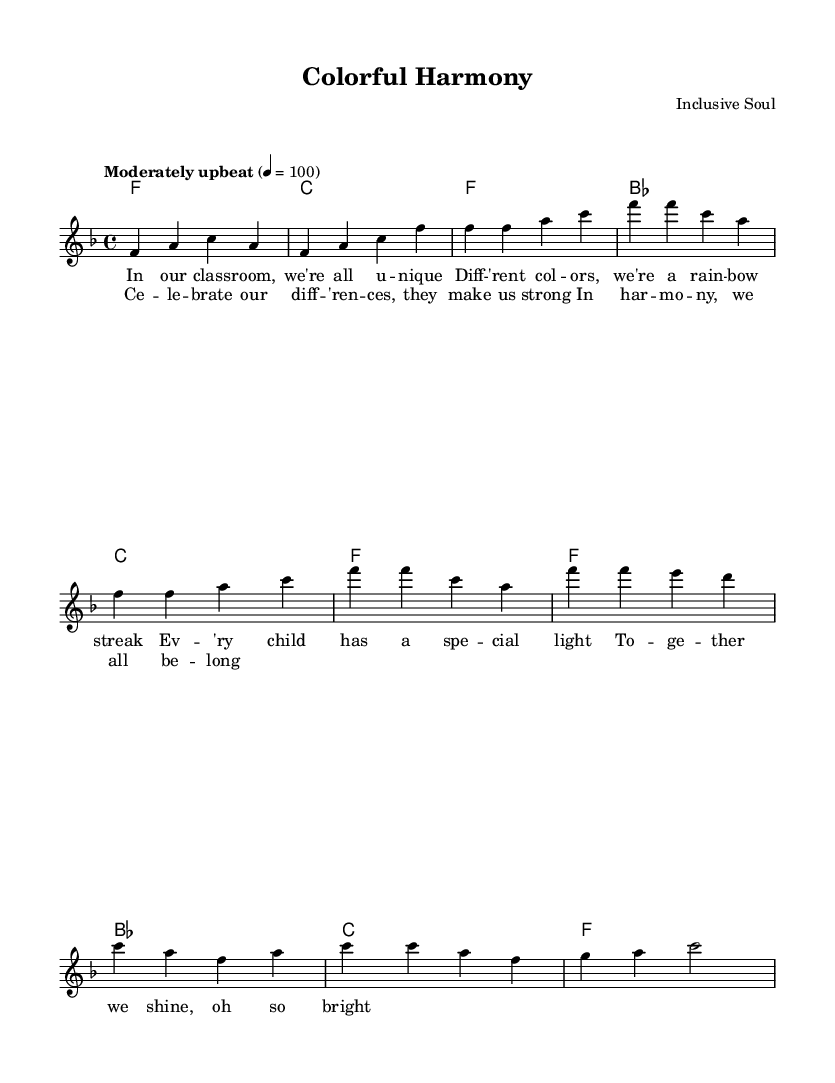What is the key signature of this music? The key signature is F major, which has one flat, B flat. This can be confirmed by looking at the beginning of the staff where the key is indicated.
Answer: F major What is the time signature for this piece? The time signature is 4/4, meaning there are four beats in each measure, and a quarter note gets one beat. This is indicated at the beginning of the staff right after the key signature.
Answer: 4/4 What is the tempo marking for this piece? The tempo marking is "Moderately upbeat," which indicates the feel and speed of the song. This is written above the staff at the beginning of the score.
Answer: Moderately upbeat How many measures are in the chorus section? The chorus section consists of four measures. This can be determined by counting the measures specifically designated for the chorus in the score.
Answer: 4 Which musical term describes the overall dynamic of the song? The overall dynamic of the song, indicated by the context of its lyrics and the feel created by the music, can be described as "uplifting." This reflects the song's theme and mood rather than a specific dynamic marking on the score.
Answer: Uplifting What is the primary theme of the lyrics in this piece? The primary theme of the lyrics focuses on celebrating differences and embracing diversity, as illustrated by the content of the words presented under the notes. This is a central message represented throughout the piece.
Answer: Celebrating differences 